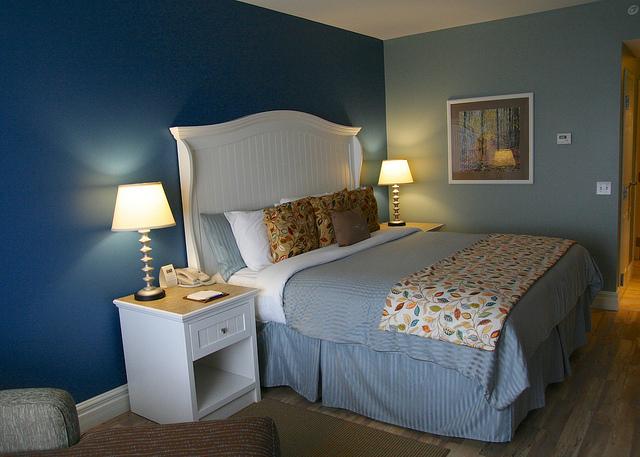What color are the lights?
Be succinct. White. How many paintings are there?
Concise answer only. 1. What color is the blanket?
Concise answer only. Blue. What is in the picture?
Keep it brief. Bedroom. What color is the bedding?
Keep it brief. Blue. Is this a hotel room?
Concise answer only. No. 